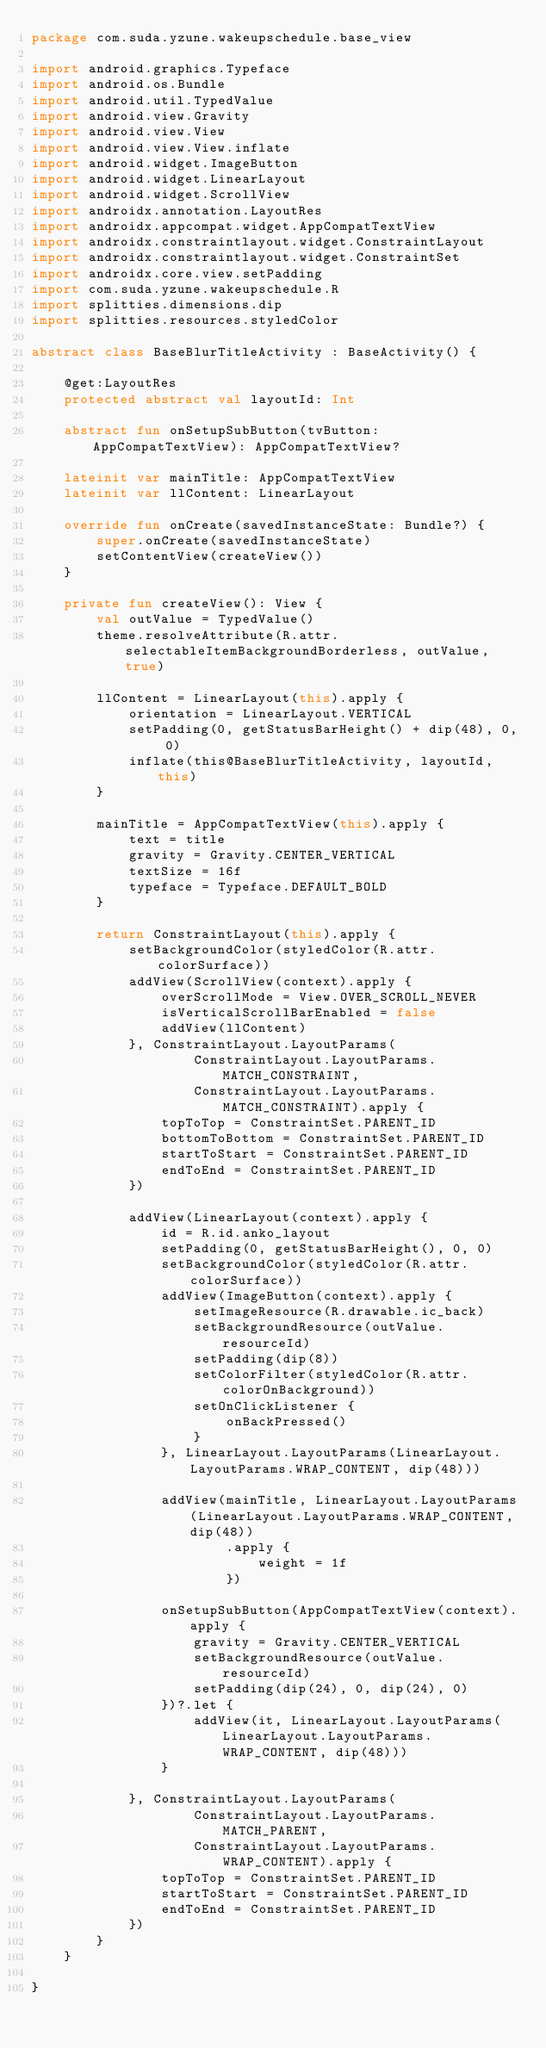Convert code to text. <code><loc_0><loc_0><loc_500><loc_500><_Kotlin_>package com.suda.yzune.wakeupschedule.base_view

import android.graphics.Typeface
import android.os.Bundle
import android.util.TypedValue
import android.view.Gravity
import android.view.View
import android.view.View.inflate
import android.widget.ImageButton
import android.widget.LinearLayout
import android.widget.ScrollView
import androidx.annotation.LayoutRes
import androidx.appcompat.widget.AppCompatTextView
import androidx.constraintlayout.widget.ConstraintLayout
import androidx.constraintlayout.widget.ConstraintSet
import androidx.core.view.setPadding
import com.suda.yzune.wakeupschedule.R
import splitties.dimensions.dip
import splitties.resources.styledColor

abstract class BaseBlurTitleActivity : BaseActivity() {

    @get:LayoutRes
    protected abstract val layoutId: Int

    abstract fun onSetupSubButton(tvButton: AppCompatTextView): AppCompatTextView?

    lateinit var mainTitle: AppCompatTextView
    lateinit var llContent: LinearLayout

    override fun onCreate(savedInstanceState: Bundle?) {
        super.onCreate(savedInstanceState)
        setContentView(createView())
    }

    private fun createView(): View {
        val outValue = TypedValue()
        theme.resolveAttribute(R.attr.selectableItemBackgroundBorderless, outValue, true)

        llContent = LinearLayout(this).apply {
            orientation = LinearLayout.VERTICAL
            setPadding(0, getStatusBarHeight() + dip(48), 0, 0)
            inflate(this@BaseBlurTitleActivity, layoutId, this)
        }

        mainTitle = AppCompatTextView(this).apply {
            text = title
            gravity = Gravity.CENTER_VERTICAL
            textSize = 16f
            typeface = Typeface.DEFAULT_BOLD
        }

        return ConstraintLayout(this).apply {
            setBackgroundColor(styledColor(R.attr.colorSurface))
            addView(ScrollView(context).apply {
                overScrollMode = View.OVER_SCROLL_NEVER
                isVerticalScrollBarEnabled = false
                addView(llContent)
            }, ConstraintLayout.LayoutParams(
                    ConstraintLayout.LayoutParams.MATCH_CONSTRAINT,
                    ConstraintLayout.LayoutParams.MATCH_CONSTRAINT).apply {
                topToTop = ConstraintSet.PARENT_ID
                bottomToBottom = ConstraintSet.PARENT_ID
                startToStart = ConstraintSet.PARENT_ID
                endToEnd = ConstraintSet.PARENT_ID
            })

            addView(LinearLayout(context).apply {
                id = R.id.anko_layout
                setPadding(0, getStatusBarHeight(), 0, 0)
                setBackgroundColor(styledColor(R.attr.colorSurface))
                addView(ImageButton(context).apply {
                    setImageResource(R.drawable.ic_back)
                    setBackgroundResource(outValue.resourceId)
                    setPadding(dip(8))
                    setColorFilter(styledColor(R.attr.colorOnBackground))
                    setOnClickListener {
                        onBackPressed()
                    }
                }, LinearLayout.LayoutParams(LinearLayout.LayoutParams.WRAP_CONTENT, dip(48)))

                addView(mainTitle, LinearLayout.LayoutParams(LinearLayout.LayoutParams.WRAP_CONTENT, dip(48))
                        .apply {
                            weight = 1f
                        })

                onSetupSubButton(AppCompatTextView(context).apply {
                    gravity = Gravity.CENTER_VERTICAL
                    setBackgroundResource(outValue.resourceId)
                    setPadding(dip(24), 0, dip(24), 0)
                })?.let {
                    addView(it, LinearLayout.LayoutParams(LinearLayout.LayoutParams.WRAP_CONTENT, dip(48)))
                }

            }, ConstraintLayout.LayoutParams(
                    ConstraintLayout.LayoutParams.MATCH_PARENT,
                    ConstraintLayout.LayoutParams.WRAP_CONTENT).apply {
                topToTop = ConstraintSet.PARENT_ID
                startToStart = ConstraintSet.PARENT_ID
                endToEnd = ConstraintSet.PARENT_ID
            })
        }
    }

}</code> 